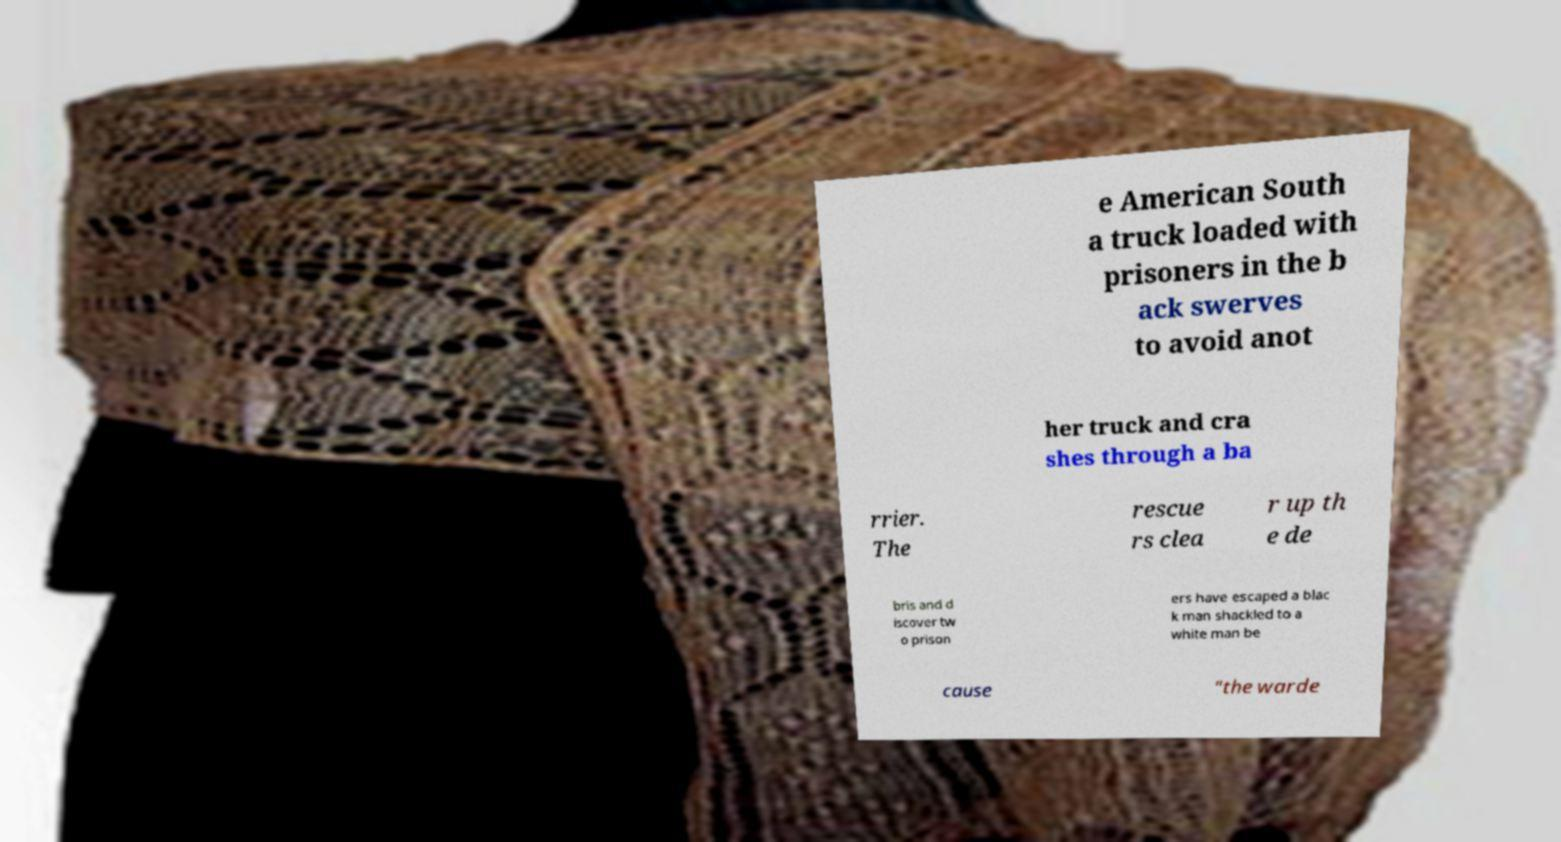Please identify and transcribe the text found in this image. e American South a truck loaded with prisoners in the b ack swerves to avoid anot her truck and cra shes through a ba rrier. The rescue rs clea r up th e de bris and d iscover tw o prison ers have escaped a blac k man shackled to a white man be cause "the warde 